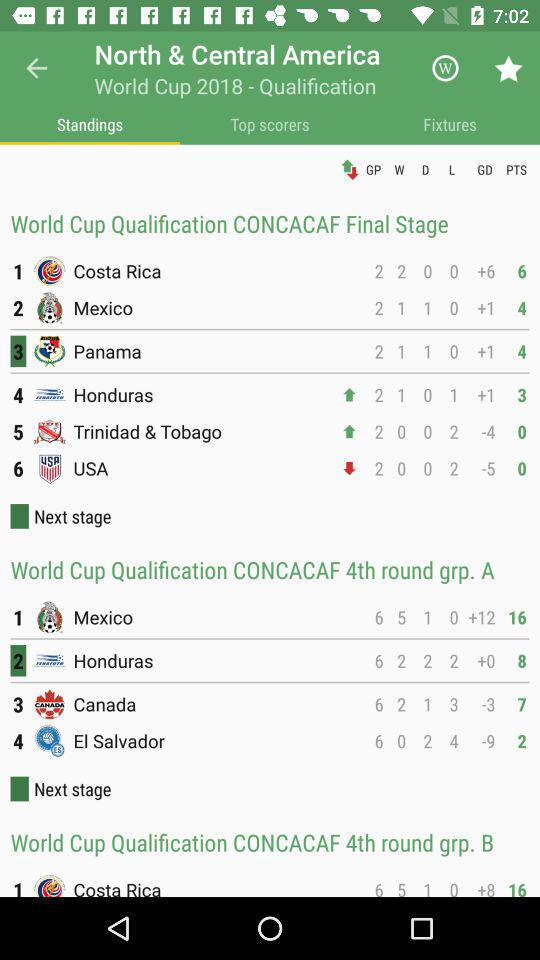How many notifications are there in "Fixtures"?
When the provided information is insufficient, respond with <no answer>. <no answer> 